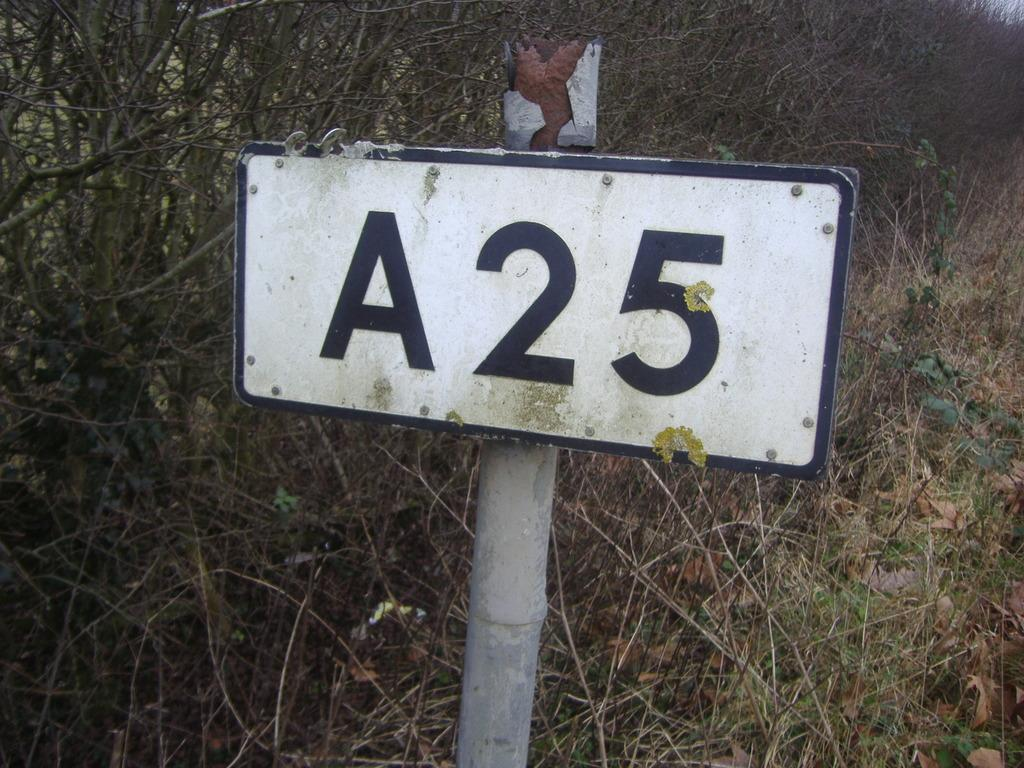<image>
Create a compact narrative representing the image presented. A street sign on a post with A25 on a white background of the sign located in a wooded area. 